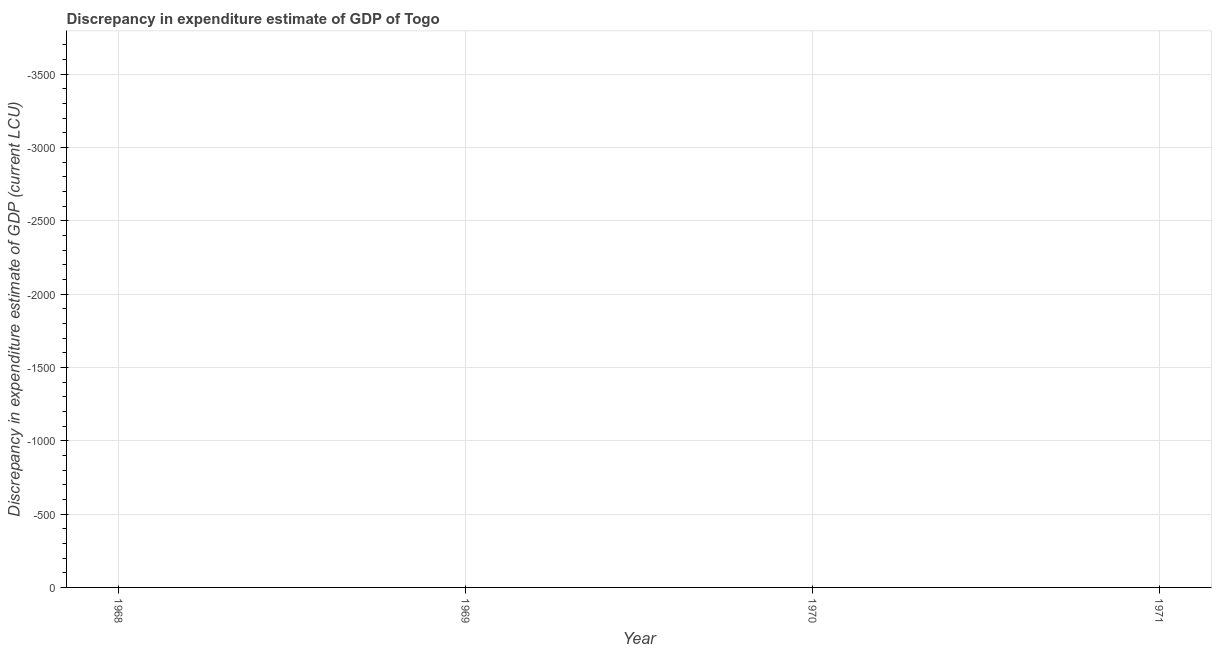In how many years, is the discrepancy in expenditure estimate of gdp greater than the average discrepancy in expenditure estimate of gdp taken over all years?
Your answer should be compact. 0. Does the discrepancy in expenditure estimate of gdp monotonically increase over the years?
Give a very brief answer. No. How many dotlines are there?
Ensure brevity in your answer.  0. How many years are there in the graph?
Offer a terse response. 4. What is the difference between two consecutive major ticks on the Y-axis?
Your answer should be compact. 500. What is the title of the graph?
Keep it short and to the point. Discrepancy in expenditure estimate of GDP of Togo. What is the label or title of the Y-axis?
Your response must be concise. Discrepancy in expenditure estimate of GDP (current LCU). What is the Discrepancy in expenditure estimate of GDP (current LCU) in 1968?
Offer a very short reply. 0. What is the Discrepancy in expenditure estimate of GDP (current LCU) in 1969?
Offer a very short reply. 0. 